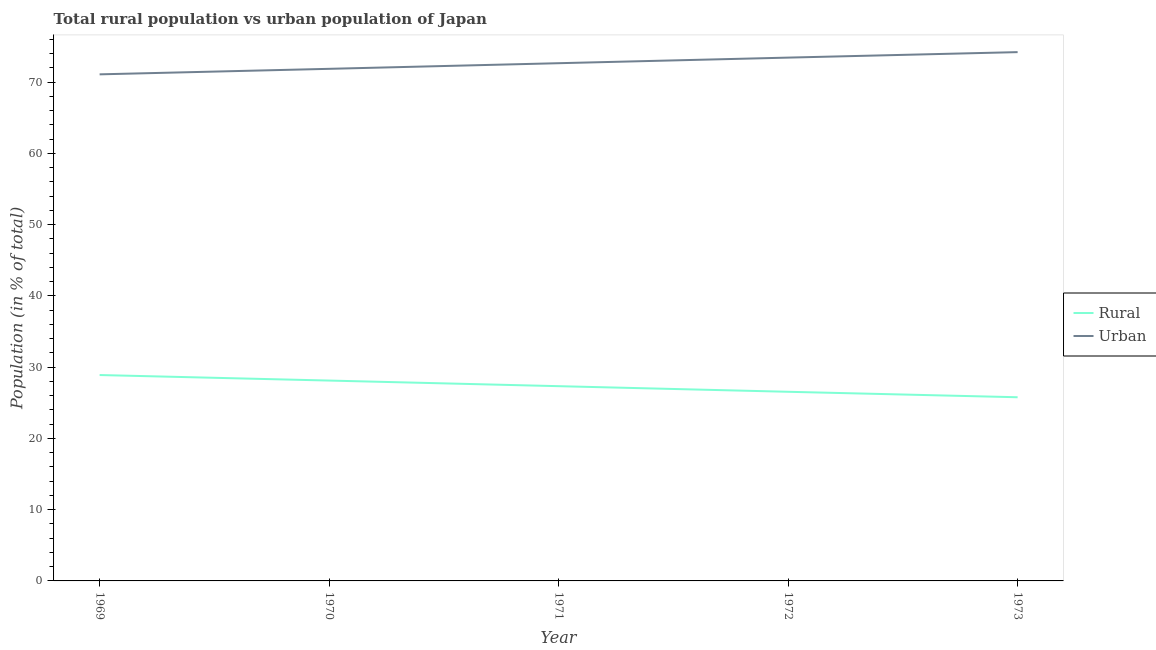Does the line corresponding to urban population intersect with the line corresponding to rural population?
Give a very brief answer. No. Is the number of lines equal to the number of legend labels?
Ensure brevity in your answer.  Yes. What is the rural population in 1971?
Offer a very short reply. 27.33. Across all years, what is the maximum rural population?
Offer a very short reply. 28.9. Across all years, what is the minimum urban population?
Provide a short and direct response. 71.1. What is the total urban population in the graph?
Ensure brevity in your answer.  363.32. What is the difference between the rural population in 1971 and that in 1973?
Your answer should be very brief. 1.55. What is the difference between the rural population in 1973 and the urban population in 1970?
Offer a very short reply. -46.1. What is the average urban population per year?
Provide a short and direct response. 72.66. In the year 1972, what is the difference between the urban population and rural population?
Give a very brief answer. 46.9. In how many years, is the urban population greater than 6 %?
Provide a short and direct response. 5. What is the ratio of the rural population in 1969 to that in 1970?
Your answer should be compact. 1.03. Is the difference between the rural population in 1971 and 1973 greater than the difference between the urban population in 1971 and 1973?
Give a very brief answer. Yes. What is the difference between the highest and the second highest rural population?
Your answer should be very brief. 0.77. What is the difference between the highest and the lowest urban population?
Offer a very short reply. 3.12. Is the rural population strictly greater than the urban population over the years?
Make the answer very short. No. Is the rural population strictly less than the urban population over the years?
Provide a succinct answer. Yes. How many lines are there?
Offer a very short reply. 2. How many years are there in the graph?
Give a very brief answer. 5. What is the difference between two consecutive major ticks on the Y-axis?
Your answer should be very brief. 10. Does the graph contain any zero values?
Your answer should be very brief. No. Does the graph contain grids?
Your answer should be compact. No. How many legend labels are there?
Offer a very short reply. 2. What is the title of the graph?
Offer a very short reply. Total rural population vs urban population of Japan. Does "Central government" appear as one of the legend labels in the graph?
Your answer should be compact. No. What is the label or title of the Y-axis?
Keep it short and to the point. Population (in % of total). What is the Population (in % of total) in Rural in 1969?
Ensure brevity in your answer.  28.9. What is the Population (in % of total) in Urban in 1969?
Make the answer very short. 71.1. What is the Population (in % of total) of Rural in 1970?
Provide a short and direct response. 28.12. What is the Population (in % of total) in Urban in 1970?
Your answer should be compact. 71.88. What is the Population (in % of total) of Rural in 1971?
Ensure brevity in your answer.  27.33. What is the Population (in % of total) of Urban in 1971?
Offer a terse response. 72.67. What is the Population (in % of total) in Rural in 1972?
Provide a short and direct response. 26.55. What is the Population (in % of total) in Urban in 1972?
Offer a terse response. 73.45. What is the Population (in % of total) in Rural in 1973?
Keep it short and to the point. 25.78. What is the Population (in % of total) of Urban in 1973?
Give a very brief answer. 74.22. Across all years, what is the maximum Population (in % of total) of Rural?
Your answer should be very brief. 28.9. Across all years, what is the maximum Population (in % of total) of Urban?
Provide a short and direct response. 74.22. Across all years, what is the minimum Population (in % of total) in Rural?
Your answer should be very brief. 25.78. Across all years, what is the minimum Population (in % of total) in Urban?
Your answer should be compact. 71.1. What is the total Population (in % of total) of Rural in the graph?
Your answer should be very brief. 136.68. What is the total Population (in % of total) in Urban in the graph?
Your answer should be compact. 363.32. What is the difference between the Population (in % of total) in Rural in 1969 and that in 1970?
Make the answer very short. 0.78. What is the difference between the Population (in % of total) in Urban in 1969 and that in 1970?
Offer a very short reply. -0.78. What is the difference between the Population (in % of total) of Rural in 1969 and that in 1971?
Your answer should be very brief. 1.56. What is the difference between the Population (in % of total) of Urban in 1969 and that in 1971?
Ensure brevity in your answer.  -1.56. What is the difference between the Population (in % of total) in Rural in 1969 and that in 1972?
Give a very brief answer. 2.35. What is the difference between the Population (in % of total) in Urban in 1969 and that in 1972?
Ensure brevity in your answer.  -2.35. What is the difference between the Population (in % of total) of Rural in 1969 and that in 1973?
Your answer should be very brief. 3.12. What is the difference between the Population (in % of total) of Urban in 1969 and that in 1973?
Offer a very short reply. -3.12. What is the difference between the Population (in % of total) in Rural in 1970 and that in 1971?
Your response must be concise. 0.79. What is the difference between the Population (in % of total) of Urban in 1970 and that in 1971?
Your answer should be very brief. -0.79. What is the difference between the Population (in % of total) of Rural in 1970 and that in 1972?
Provide a succinct answer. 1.57. What is the difference between the Population (in % of total) of Urban in 1970 and that in 1972?
Provide a succinct answer. -1.57. What is the difference between the Population (in % of total) of Rural in 1970 and that in 1973?
Your response must be concise. 2.34. What is the difference between the Population (in % of total) of Urban in 1970 and that in 1973?
Give a very brief answer. -2.34. What is the difference between the Population (in % of total) of Rural in 1971 and that in 1972?
Provide a succinct answer. 0.79. What is the difference between the Population (in % of total) in Urban in 1971 and that in 1972?
Make the answer very short. -0.79. What is the difference between the Population (in % of total) in Rural in 1971 and that in 1973?
Ensure brevity in your answer.  1.55. What is the difference between the Population (in % of total) in Urban in 1971 and that in 1973?
Give a very brief answer. -1.55. What is the difference between the Population (in % of total) in Rural in 1972 and that in 1973?
Ensure brevity in your answer.  0.77. What is the difference between the Population (in % of total) of Urban in 1972 and that in 1973?
Give a very brief answer. -0.77. What is the difference between the Population (in % of total) of Rural in 1969 and the Population (in % of total) of Urban in 1970?
Give a very brief answer. -42.98. What is the difference between the Population (in % of total) of Rural in 1969 and the Population (in % of total) of Urban in 1971?
Your answer should be compact. -43.77. What is the difference between the Population (in % of total) of Rural in 1969 and the Population (in % of total) of Urban in 1972?
Provide a short and direct response. -44.55. What is the difference between the Population (in % of total) in Rural in 1969 and the Population (in % of total) in Urban in 1973?
Your answer should be very brief. -45.32. What is the difference between the Population (in % of total) in Rural in 1970 and the Population (in % of total) in Urban in 1971?
Make the answer very short. -44.54. What is the difference between the Population (in % of total) in Rural in 1970 and the Population (in % of total) in Urban in 1972?
Offer a terse response. -45.33. What is the difference between the Population (in % of total) in Rural in 1970 and the Population (in % of total) in Urban in 1973?
Provide a succinct answer. -46.1. What is the difference between the Population (in % of total) in Rural in 1971 and the Population (in % of total) in Urban in 1972?
Ensure brevity in your answer.  -46.12. What is the difference between the Population (in % of total) in Rural in 1971 and the Population (in % of total) in Urban in 1973?
Your response must be concise. -46.89. What is the difference between the Population (in % of total) in Rural in 1972 and the Population (in % of total) in Urban in 1973?
Keep it short and to the point. -47.67. What is the average Population (in % of total) of Rural per year?
Your response must be concise. 27.34. What is the average Population (in % of total) of Urban per year?
Offer a terse response. 72.66. In the year 1969, what is the difference between the Population (in % of total) in Rural and Population (in % of total) in Urban?
Make the answer very short. -42.2. In the year 1970, what is the difference between the Population (in % of total) in Rural and Population (in % of total) in Urban?
Make the answer very short. -43.75. In the year 1971, what is the difference between the Population (in % of total) in Rural and Population (in % of total) in Urban?
Provide a succinct answer. -45.33. In the year 1972, what is the difference between the Population (in % of total) of Rural and Population (in % of total) of Urban?
Your answer should be very brief. -46.9. In the year 1973, what is the difference between the Population (in % of total) in Rural and Population (in % of total) in Urban?
Provide a succinct answer. -48.44. What is the ratio of the Population (in % of total) of Rural in 1969 to that in 1970?
Your answer should be compact. 1.03. What is the ratio of the Population (in % of total) of Urban in 1969 to that in 1970?
Ensure brevity in your answer.  0.99. What is the ratio of the Population (in % of total) in Rural in 1969 to that in 1971?
Your answer should be compact. 1.06. What is the ratio of the Population (in % of total) in Urban in 1969 to that in 1971?
Offer a very short reply. 0.98. What is the ratio of the Population (in % of total) of Rural in 1969 to that in 1972?
Offer a terse response. 1.09. What is the ratio of the Population (in % of total) in Urban in 1969 to that in 1972?
Keep it short and to the point. 0.97. What is the ratio of the Population (in % of total) in Rural in 1969 to that in 1973?
Make the answer very short. 1.12. What is the ratio of the Population (in % of total) in Urban in 1969 to that in 1973?
Provide a short and direct response. 0.96. What is the ratio of the Population (in % of total) of Rural in 1970 to that in 1971?
Offer a terse response. 1.03. What is the ratio of the Population (in % of total) of Urban in 1970 to that in 1971?
Offer a terse response. 0.99. What is the ratio of the Population (in % of total) of Rural in 1970 to that in 1972?
Your answer should be compact. 1.06. What is the ratio of the Population (in % of total) in Urban in 1970 to that in 1972?
Make the answer very short. 0.98. What is the ratio of the Population (in % of total) in Rural in 1970 to that in 1973?
Provide a succinct answer. 1.09. What is the ratio of the Population (in % of total) in Urban in 1970 to that in 1973?
Your response must be concise. 0.97. What is the ratio of the Population (in % of total) of Rural in 1971 to that in 1972?
Offer a very short reply. 1.03. What is the ratio of the Population (in % of total) in Urban in 1971 to that in 1972?
Ensure brevity in your answer.  0.99. What is the ratio of the Population (in % of total) of Rural in 1971 to that in 1973?
Your answer should be very brief. 1.06. What is the ratio of the Population (in % of total) in Urban in 1971 to that in 1973?
Make the answer very short. 0.98. What is the ratio of the Population (in % of total) of Rural in 1972 to that in 1973?
Provide a short and direct response. 1.03. What is the difference between the highest and the second highest Population (in % of total) of Rural?
Provide a succinct answer. 0.78. What is the difference between the highest and the second highest Population (in % of total) in Urban?
Provide a succinct answer. 0.77. What is the difference between the highest and the lowest Population (in % of total) of Rural?
Offer a very short reply. 3.12. What is the difference between the highest and the lowest Population (in % of total) of Urban?
Your response must be concise. 3.12. 